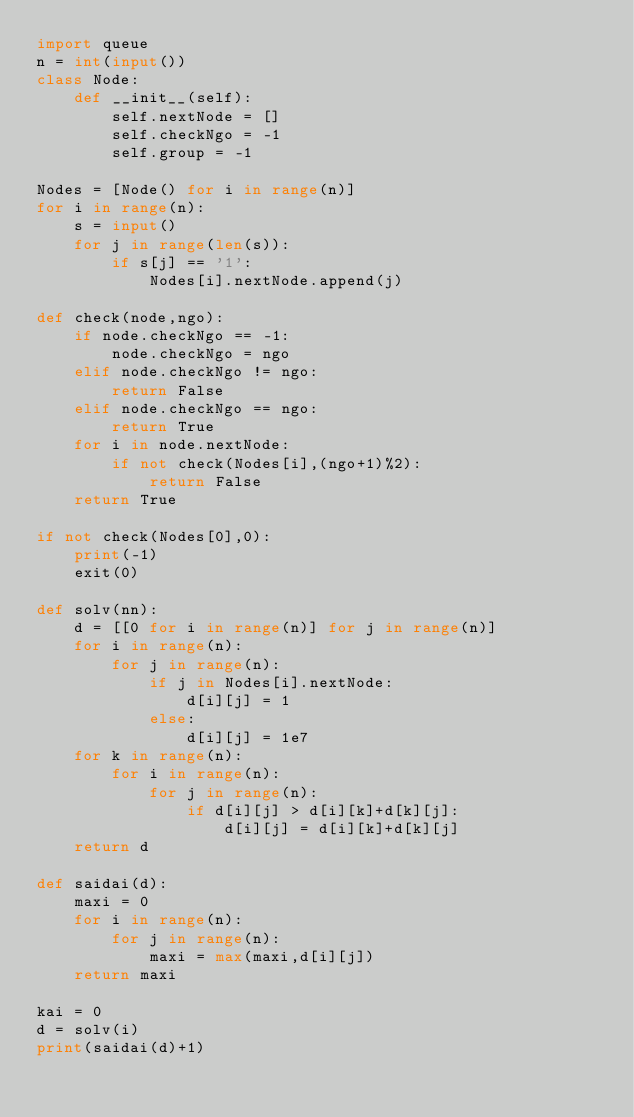<code> <loc_0><loc_0><loc_500><loc_500><_Python_>import queue
n = int(input())
class Node:
    def __init__(self):
        self.nextNode = []
        self.checkNgo = -1
        self.group = -1
        
Nodes = [Node() for i in range(n)]
for i in range(n):
    s = input()
    for j in range(len(s)):
        if s[j] == '1':
            Nodes[i].nextNode.append(j)
            
def check(node,ngo):
    if node.checkNgo == -1:
        node.checkNgo = ngo
    elif node.checkNgo != ngo:
        return False
    elif node.checkNgo == ngo:
        return True
    for i in node.nextNode:
        if not check(Nodes[i],(ngo+1)%2):
            return False
    return True
    
if not check(Nodes[0],0):
    print(-1)
    exit(0)
    
def solv(nn):
    d = [[0 for i in range(n)] for j in range(n)]
    for i in range(n):
        for j in range(n):
            if j in Nodes[i].nextNode:
                d[i][j] = 1
            else:
                d[i][j] = 1e7
    for k in range(n):
        for i in range(n):
            for j in range(n):
                if d[i][j] > d[i][k]+d[k][j]:
                    d[i][j] = d[i][k]+d[k][j]
    return d
    
def saidai(d):
    maxi = 0
    for i in range(n):
        for j in range(n):
            maxi = max(maxi,d[i][j])
    return maxi
    
kai = 0
d = solv(i)
print(saidai(d)+1)</code> 